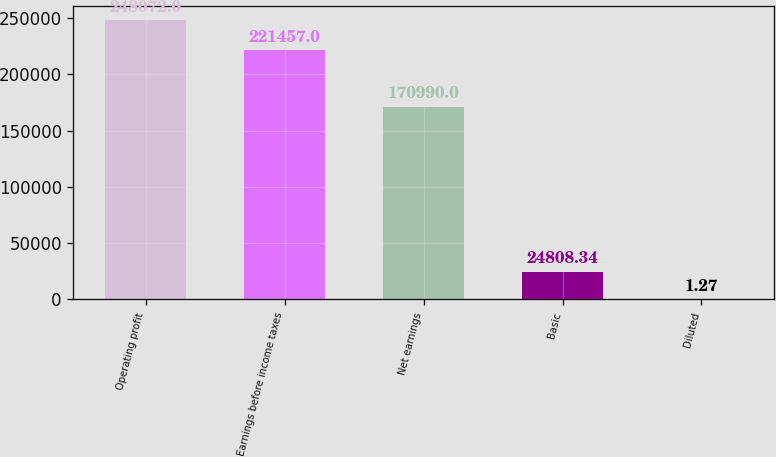Convert chart to OTSL. <chart><loc_0><loc_0><loc_500><loc_500><bar_chart><fcel>Operating profit<fcel>Earnings before income taxes<fcel>Net earnings<fcel>Basic<fcel>Diluted<nl><fcel>248072<fcel>221457<fcel>170990<fcel>24808.3<fcel>1.27<nl></chart> 